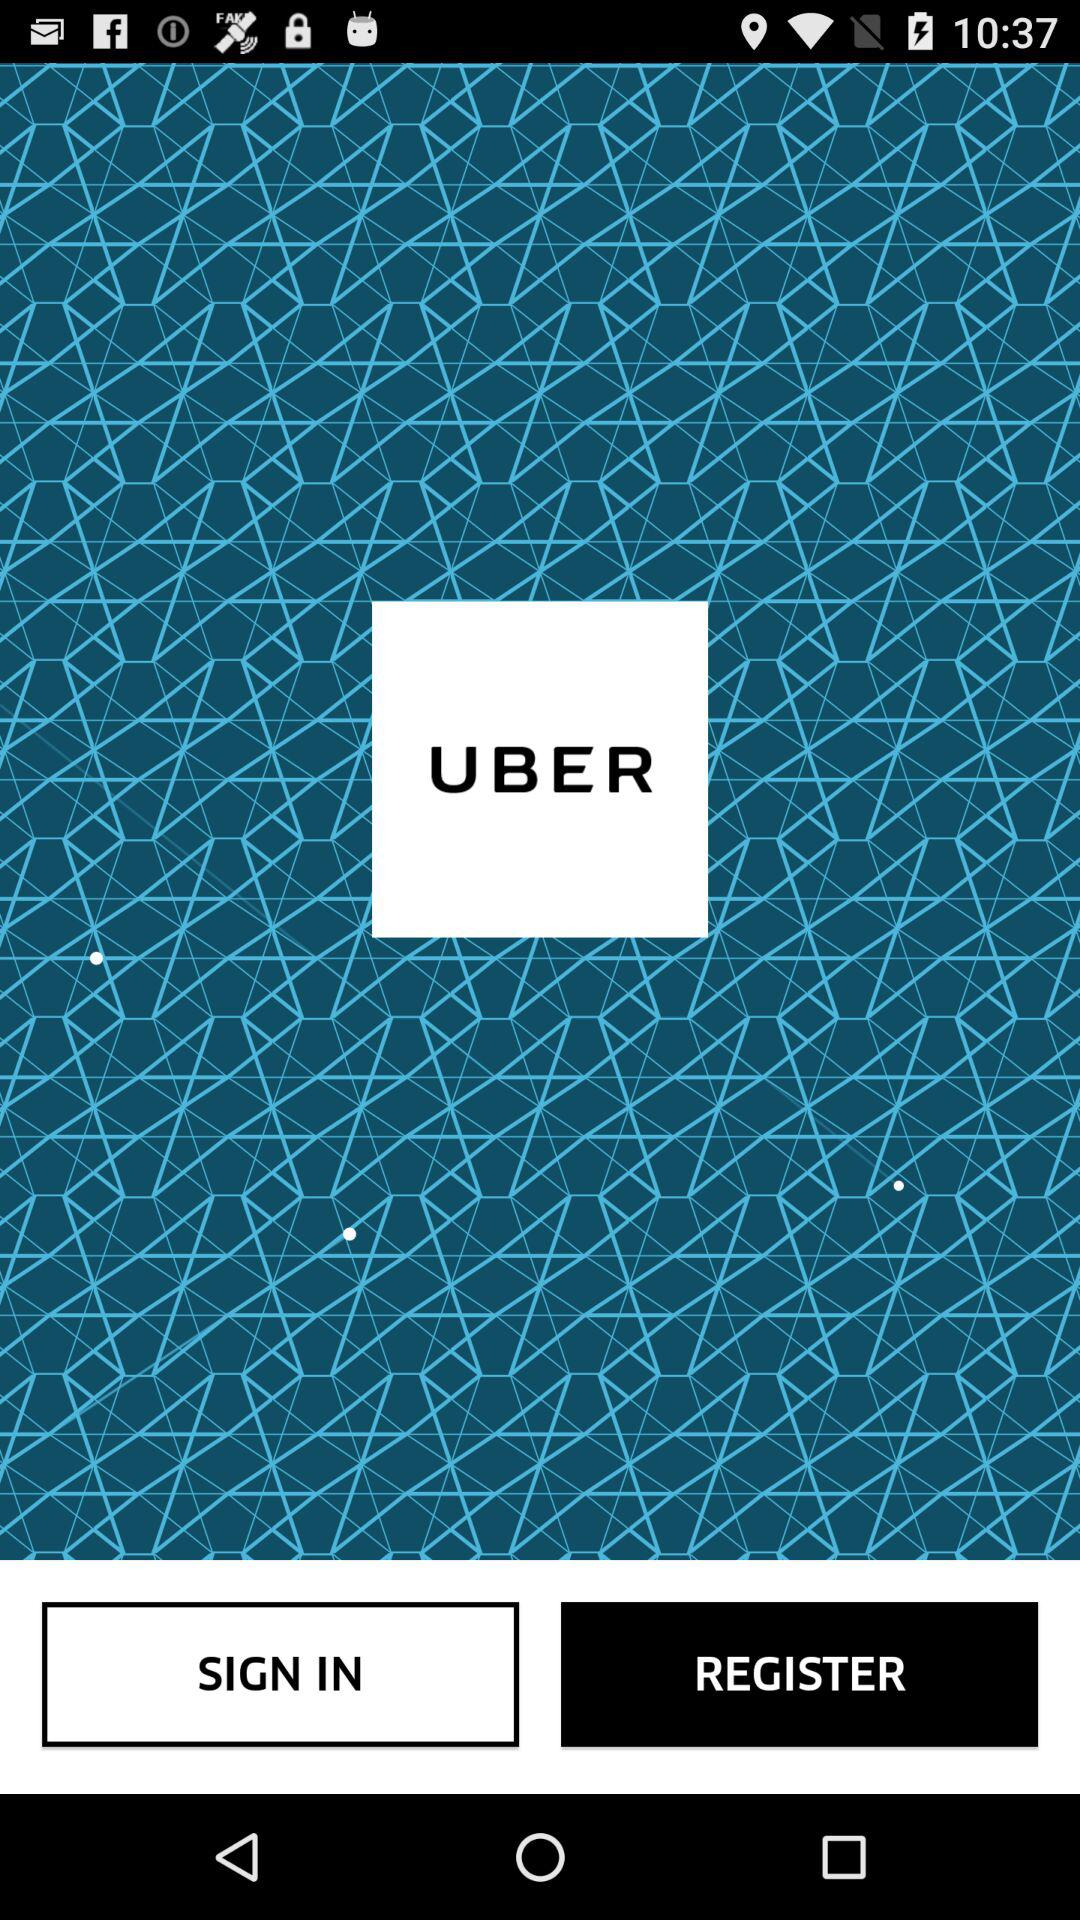Who is this application powered by?
When the provided information is insufficient, respond with <no answer>. <no answer> 